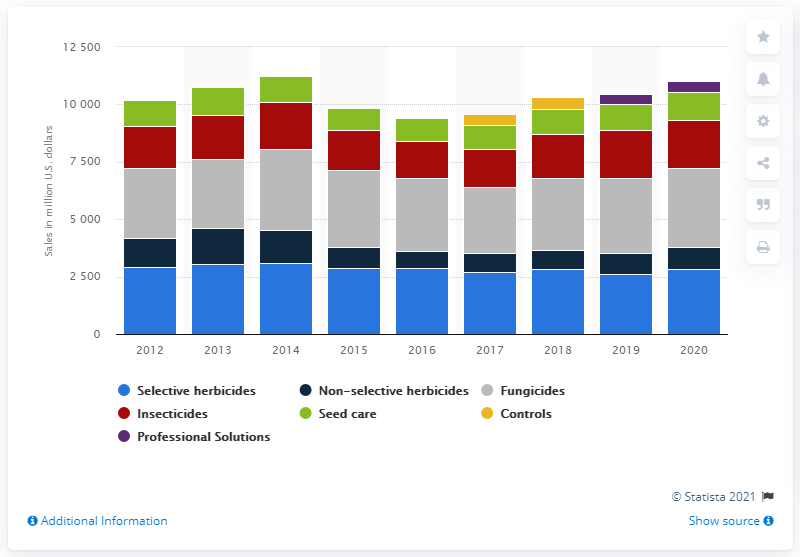Give some essential details in this illustration. Syngenta AG's sales of selective herbicides in the crop protection segment in the U.S. in 2020 were approximately $2,831. 